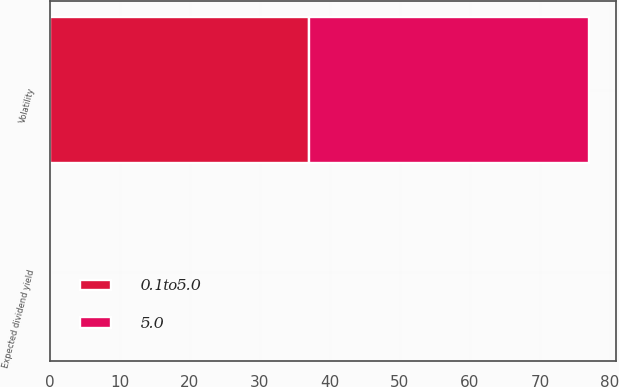Convert chart. <chart><loc_0><loc_0><loc_500><loc_500><stacked_bar_chart><ecel><fcel>Expected dividend yield<fcel>Volatility<nl><fcel>5.0<fcel>0<fcel>40<nl><fcel>0.1to5.0<fcel>0<fcel>37<nl></chart> 